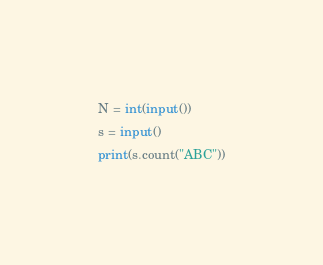Convert code to text. <code><loc_0><loc_0><loc_500><loc_500><_Python_>N = int(input())
s = input()
print(s.count("ABC"))</code> 